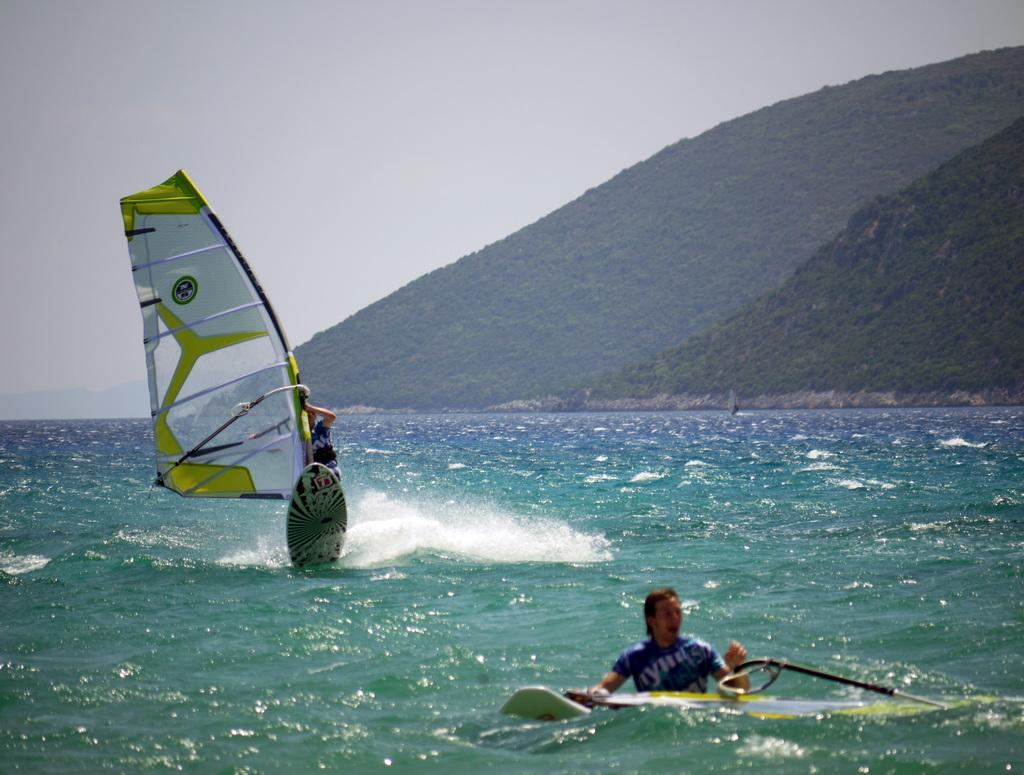What activity is the person in the image engaged in? There is a person windsurfing in the image. Can you describe the other person in the image? There is a person in the water in the image. What can be seen in the distance in the image? Mountains are visible in the background of the image. What is visible at the top of the image? The sky is visible at the top of the image. What is present at the bottom of the image? Water is present at the bottom of the image. What type of pump is being used by the person windsurfing in the image? There is no pump visible in the image; the person is windsurfing, which does not require a pump. What color is the coat worn by the person in the water in the image? There is no coat visible in the image; the person in the water is not wearing any clothing. 